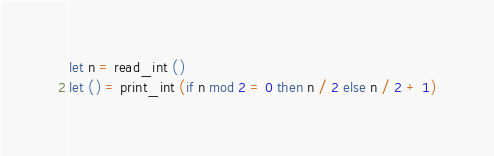Convert code to text. <code><loc_0><loc_0><loc_500><loc_500><_OCaml_>let n = read_int ()
let () = print_int (if n mod 2 = 0 then n / 2 else n / 2 + 1)</code> 